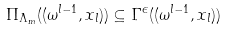<formula> <loc_0><loc_0><loc_500><loc_500>\Pi _ { \Lambda _ { m } } ( ( \omega ^ { l - 1 } , x _ { l } ) ) \subseteq \Gamma ^ { \epsilon } ( ( \omega ^ { l - 1 } , x _ { l } ) )</formula> 